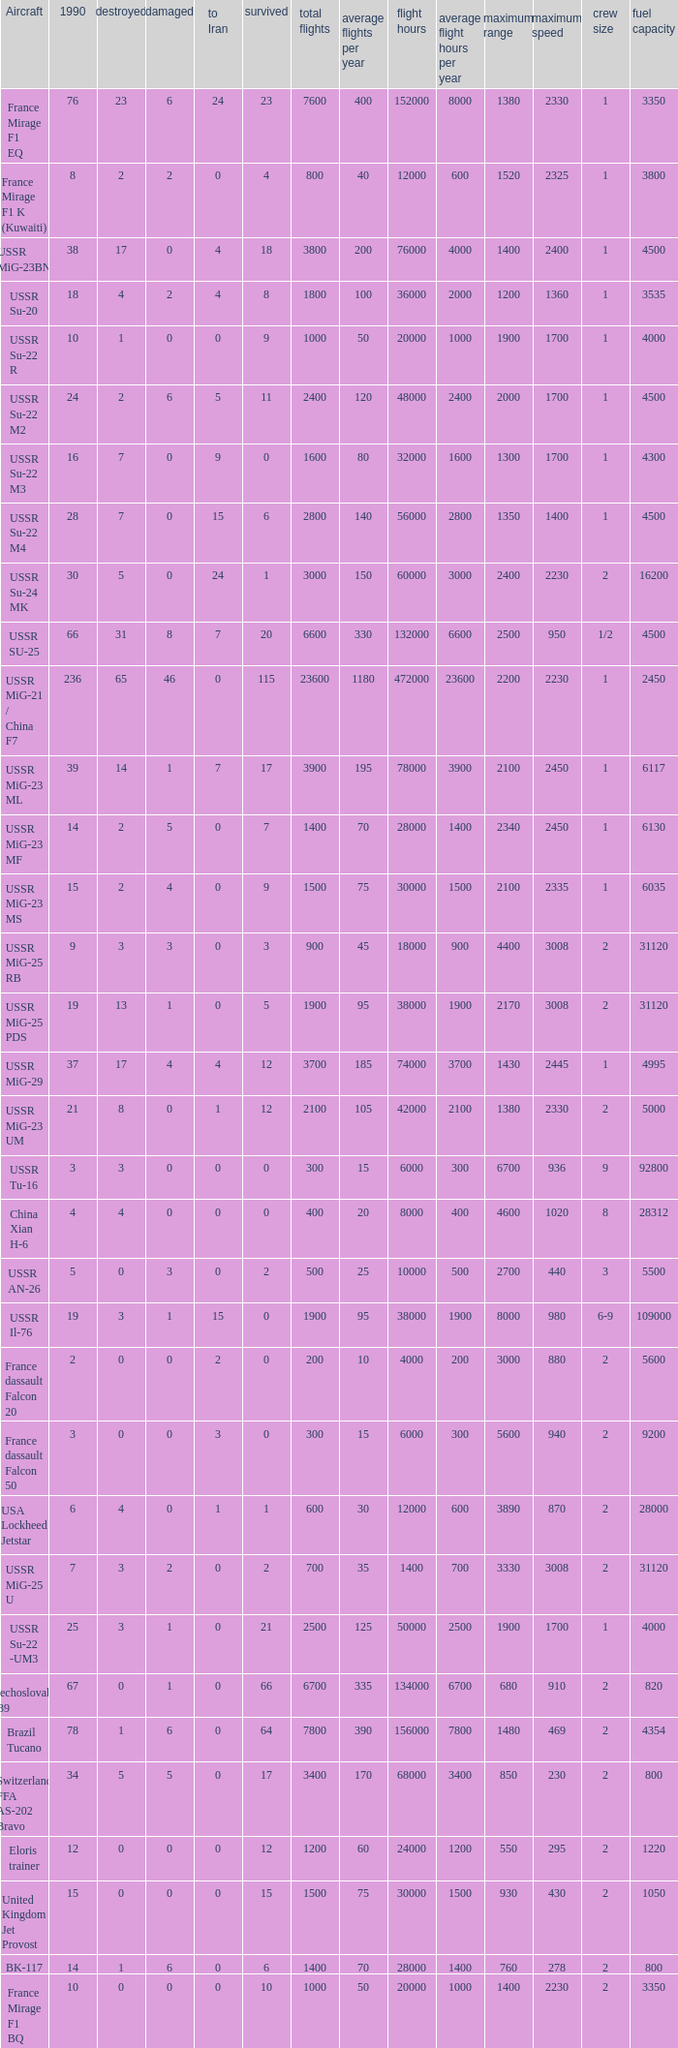If there were 14 in 1990 and 6 survived how many were destroyed? 1.0. 